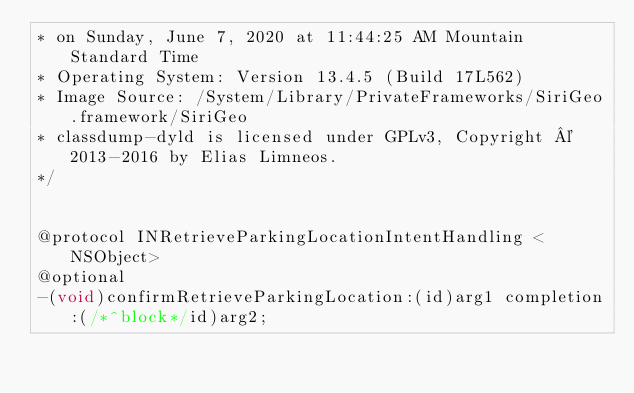<code> <loc_0><loc_0><loc_500><loc_500><_C_>* on Sunday, June 7, 2020 at 11:44:25 AM Mountain Standard Time
* Operating System: Version 13.4.5 (Build 17L562)
* Image Source: /System/Library/PrivateFrameworks/SiriGeo.framework/SiriGeo
* classdump-dyld is licensed under GPLv3, Copyright © 2013-2016 by Elias Limneos.
*/


@protocol INRetrieveParkingLocationIntentHandling <NSObject>
@optional
-(void)confirmRetrieveParkingLocation:(id)arg1 completion:(/*^block*/id)arg2;</code> 